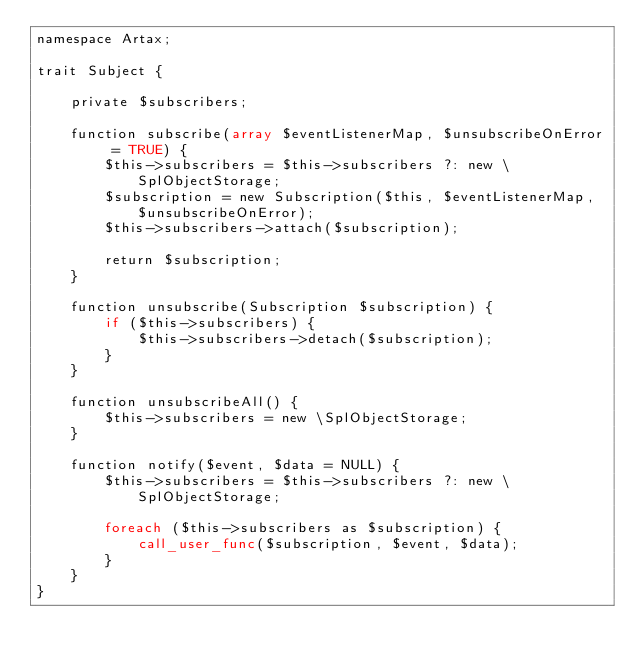<code> <loc_0><loc_0><loc_500><loc_500><_PHP_>namespace Artax;

trait Subject {
    
    private $subscribers;
    
    function subscribe(array $eventListenerMap, $unsubscribeOnError = TRUE) {
        $this->subscribers = $this->subscribers ?: new \SplObjectStorage;
        $subscription = new Subscription($this, $eventListenerMap, $unsubscribeOnError);
        $this->subscribers->attach($subscription);
        
        return $subscription;
    }
    
    function unsubscribe(Subscription $subscription) {
        if ($this->subscribers) {
            $this->subscribers->detach($subscription);
        }
    }
    
    function unsubscribeAll() {
        $this->subscribers = new \SplObjectStorage;
    }
    
    function notify($event, $data = NULL) {
        $this->subscribers = $this->subscribers ?: new \SplObjectStorage;
        
        foreach ($this->subscribers as $subscription) {
            call_user_func($subscription, $event, $data);
        }
    }
}
</code> 